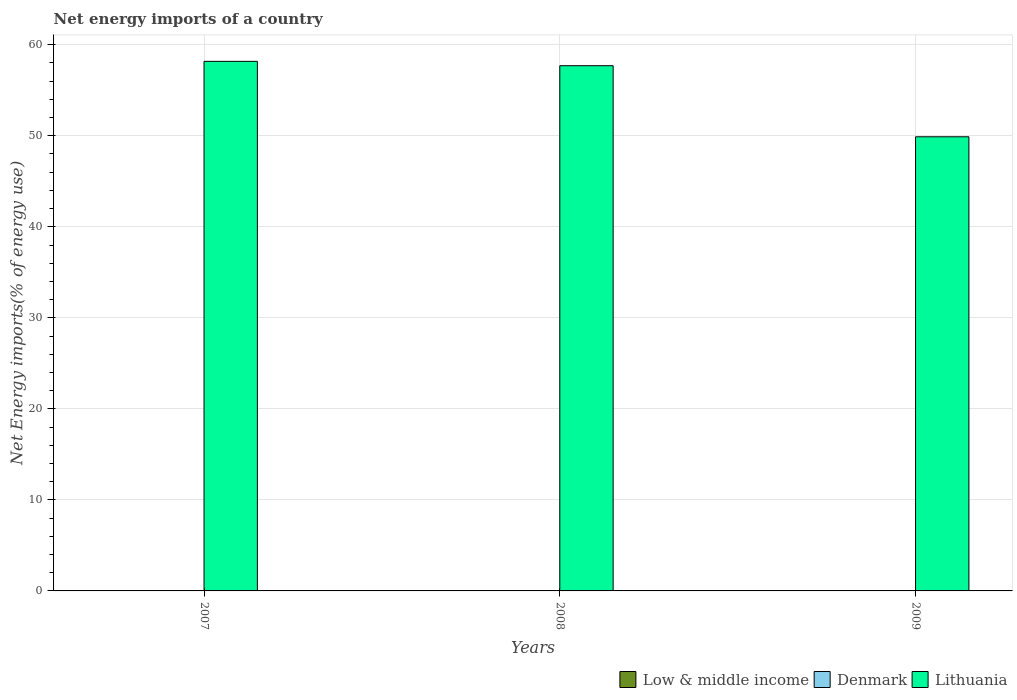How many bars are there on the 1st tick from the left?
Ensure brevity in your answer.  1. How many bars are there on the 3rd tick from the right?
Give a very brief answer. 1. What is the label of the 3rd group of bars from the left?
Your response must be concise. 2009. In how many cases, is the number of bars for a given year not equal to the number of legend labels?
Provide a succinct answer. 3. What is the net energy imports in Low & middle income in 2007?
Ensure brevity in your answer.  0. Across all years, what is the minimum net energy imports in Denmark?
Provide a succinct answer. 0. In which year was the net energy imports in Lithuania maximum?
Provide a short and direct response. 2007. What is the difference between the net energy imports in Lithuania in 2007 and that in 2008?
Provide a succinct answer. 0.48. What is the difference between the net energy imports in Low & middle income in 2008 and the net energy imports in Lithuania in 2009?
Offer a terse response. -49.89. What is the average net energy imports in Denmark per year?
Make the answer very short. 0. In how many years, is the net energy imports in Lithuania greater than 40 %?
Offer a terse response. 3. What is the ratio of the net energy imports in Lithuania in 2007 to that in 2008?
Ensure brevity in your answer.  1.01. What is the difference between the highest and the second highest net energy imports in Lithuania?
Offer a very short reply. 0.48. What is the difference between the highest and the lowest net energy imports in Lithuania?
Offer a very short reply. 8.29. Is the sum of the net energy imports in Lithuania in 2008 and 2009 greater than the maximum net energy imports in Denmark across all years?
Offer a very short reply. Yes. How many years are there in the graph?
Your answer should be compact. 3. What is the difference between two consecutive major ticks on the Y-axis?
Your answer should be compact. 10. Are the values on the major ticks of Y-axis written in scientific E-notation?
Make the answer very short. No. Does the graph contain any zero values?
Your response must be concise. Yes. Does the graph contain grids?
Provide a succinct answer. Yes. What is the title of the graph?
Provide a succinct answer. Net energy imports of a country. What is the label or title of the Y-axis?
Offer a terse response. Net Energy imports(% of energy use). What is the Net Energy imports(% of energy use) in Lithuania in 2007?
Your response must be concise. 58.18. What is the Net Energy imports(% of energy use) in Low & middle income in 2008?
Your response must be concise. 0. What is the Net Energy imports(% of energy use) of Lithuania in 2008?
Keep it short and to the point. 57.7. What is the Net Energy imports(% of energy use) of Low & middle income in 2009?
Offer a terse response. 0. What is the Net Energy imports(% of energy use) in Denmark in 2009?
Give a very brief answer. 0. What is the Net Energy imports(% of energy use) in Lithuania in 2009?
Keep it short and to the point. 49.89. Across all years, what is the maximum Net Energy imports(% of energy use) in Lithuania?
Provide a short and direct response. 58.18. Across all years, what is the minimum Net Energy imports(% of energy use) in Lithuania?
Offer a terse response. 49.89. What is the total Net Energy imports(% of energy use) in Denmark in the graph?
Give a very brief answer. 0. What is the total Net Energy imports(% of energy use) in Lithuania in the graph?
Provide a short and direct response. 165.76. What is the difference between the Net Energy imports(% of energy use) of Lithuania in 2007 and that in 2008?
Offer a terse response. 0.48. What is the difference between the Net Energy imports(% of energy use) in Lithuania in 2007 and that in 2009?
Your answer should be very brief. 8.29. What is the difference between the Net Energy imports(% of energy use) of Lithuania in 2008 and that in 2009?
Offer a very short reply. 7.81. What is the average Net Energy imports(% of energy use) of Lithuania per year?
Make the answer very short. 55.25. What is the ratio of the Net Energy imports(% of energy use) of Lithuania in 2007 to that in 2008?
Offer a very short reply. 1.01. What is the ratio of the Net Energy imports(% of energy use) of Lithuania in 2007 to that in 2009?
Make the answer very short. 1.17. What is the ratio of the Net Energy imports(% of energy use) in Lithuania in 2008 to that in 2009?
Give a very brief answer. 1.16. What is the difference between the highest and the second highest Net Energy imports(% of energy use) of Lithuania?
Ensure brevity in your answer.  0.48. What is the difference between the highest and the lowest Net Energy imports(% of energy use) of Lithuania?
Offer a very short reply. 8.29. 